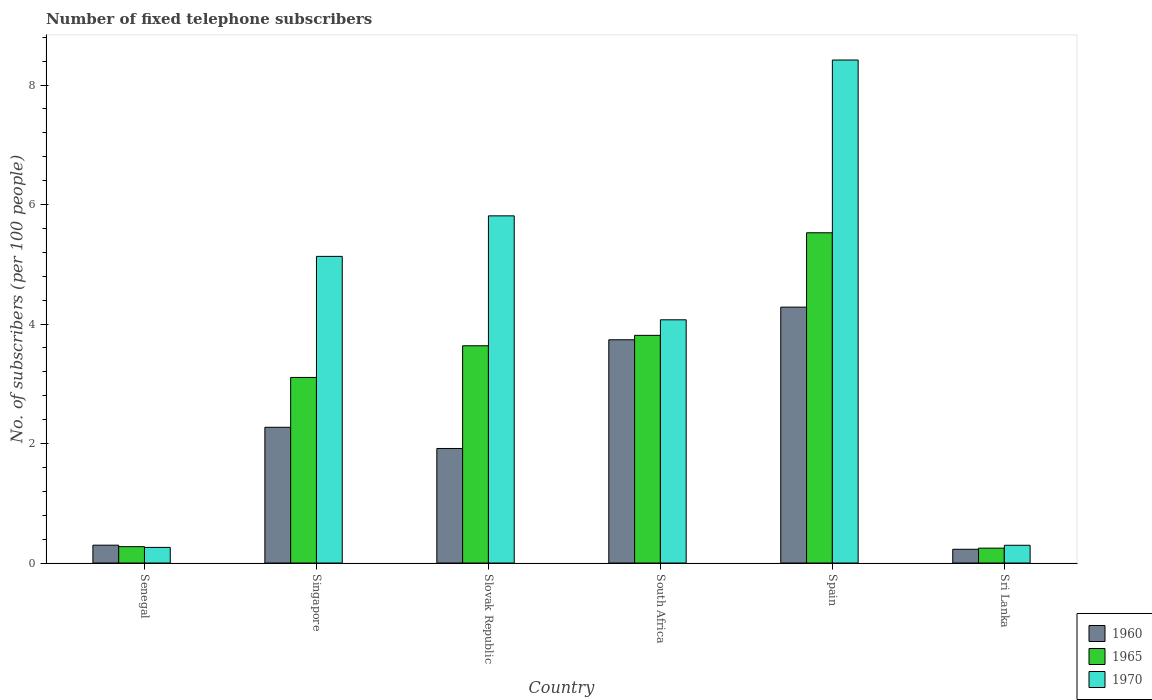How many different coloured bars are there?
Your response must be concise. 3. How many bars are there on the 1st tick from the right?
Your answer should be compact. 3. What is the label of the 3rd group of bars from the left?
Keep it short and to the point. Slovak Republic. What is the number of fixed telephone subscribers in 1970 in South Africa?
Give a very brief answer. 4.07. Across all countries, what is the maximum number of fixed telephone subscribers in 1965?
Ensure brevity in your answer.  5.53. Across all countries, what is the minimum number of fixed telephone subscribers in 1970?
Keep it short and to the point. 0.26. In which country was the number of fixed telephone subscribers in 1965 minimum?
Provide a succinct answer. Sri Lanka. What is the total number of fixed telephone subscribers in 1970 in the graph?
Offer a very short reply. 23.99. What is the difference between the number of fixed telephone subscribers in 1970 in Singapore and that in South Africa?
Give a very brief answer. 1.06. What is the difference between the number of fixed telephone subscribers in 1970 in Singapore and the number of fixed telephone subscribers in 1960 in Senegal?
Your answer should be very brief. 4.83. What is the average number of fixed telephone subscribers in 1960 per country?
Keep it short and to the point. 2.12. What is the difference between the number of fixed telephone subscribers of/in 1970 and number of fixed telephone subscribers of/in 1965 in South Africa?
Your answer should be compact. 0.26. In how many countries, is the number of fixed telephone subscribers in 1970 greater than 3.6?
Give a very brief answer. 4. What is the ratio of the number of fixed telephone subscribers in 1970 in Spain to that in Sri Lanka?
Your response must be concise. 28.33. What is the difference between the highest and the second highest number of fixed telephone subscribers in 1960?
Give a very brief answer. -1.46. What is the difference between the highest and the lowest number of fixed telephone subscribers in 1960?
Give a very brief answer. 4.05. Is the sum of the number of fixed telephone subscribers in 1960 in Singapore and Spain greater than the maximum number of fixed telephone subscribers in 1970 across all countries?
Your answer should be compact. No. What does the 3rd bar from the left in Senegal represents?
Make the answer very short. 1970. What does the 2nd bar from the right in Senegal represents?
Offer a very short reply. 1965. How many countries are there in the graph?
Provide a short and direct response. 6. Does the graph contain any zero values?
Your response must be concise. No. Does the graph contain grids?
Offer a terse response. No. What is the title of the graph?
Your answer should be compact. Number of fixed telephone subscribers. What is the label or title of the Y-axis?
Offer a terse response. No. of subscribers (per 100 people). What is the No. of subscribers (per 100 people) of 1960 in Senegal?
Provide a succinct answer. 0.3. What is the No. of subscribers (per 100 people) of 1965 in Senegal?
Your answer should be very brief. 0.27. What is the No. of subscribers (per 100 people) in 1970 in Senegal?
Your answer should be compact. 0.26. What is the No. of subscribers (per 100 people) in 1960 in Singapore?
Keep it short and to the point. 2.27. What is the No. of subscribers (per 100 people) of 1965 in Singapore?
Your response must be concise. 3.11. What is the No. of subscribers (per 100 people) in 1970 in Singapore?
Keep it short and to the point. 5.13. What is the No. of subscribers (per 100 people) of 1960 in Slovak Republic?
Offer a terse response. 1.92. What is the No. of subscribers (per 100 people) in 1965 in Slovak Republic?
Ensure brevity in your answer.  3.64. What is the No. of subscribers (per 100 people) in 1970 in Slovak Republic?
Keep it short and to the point. 5.81. What is the No. of subscribers (per 100 people) of 1960 in South Africa?
Your response must be concise. 3.74. What is the No. of subscribers (per 100 people) in 1965 in South Africa?
Your answer should be very brief. 3.81. What is the No. of subscribers (per 100 people) in 1970 in South Africa?
Make the answer very short. 4.07. What is the No. of subscribers (per 100 people) of 1960 in Spain?
Make the answer very short. 4.28. What is the No. of subscribers (per 100 people) of 1965 in Spain?
Your answer should be very brief. 5.53. What is the No. of subscribers (per 100 people) in 1970 in Spain?
Provide a succinct answer. 8.42. What is the No. of subscribers (per 100 people) in 1960 in Sri Lanka?
Offer a terse response. 0.23. What is the No. of subscribers (per 100 people) of 1965 in Sri Lanka?
Provide a succinct answer. 0.25. What is the No. of subscribers (per 100 people) in 1970 in Sri Lanka?
Give a very brief answer. 0.3. Across all countries, what is the maximum No. of subscribers (per 100 people) in 1960?
Offer a terse response. 4.28. Across all countries, what is the maximum No. of subscribers (per 100 people) of 1965?
Your response must be concise. 5.53. Across all countries, what is the maximum No. of subscribers (per 100 people) in 1970?
Offer a terse response. 8.42. Across all countries, what is the minimum No. of subscribers (per 100 people) of 1960?
Ensure brevity in your answer.  0.23. Across all countries, what is the minimum No. of subscribers (per 100 people) of 1965?
Your answer should be compact. 0.25. Across all countries, what is the minimum No. of subscribers (per 100 people) in 1970?
Your response must be concise. 0.26. What is the total No. of subscribers (per 100 people) in 1960 in the graph?
Give a very brief answer. 12.74. What is the total No. of subscribers (per 100 people) in 1965 in the graph?
Offer a terse response. 16.6. What is the total No. of subscribers (per 100 people) in 1970 in the graph?
Your answer should be compact. 23.99. What is the difference between the No. of subscribers (per 100 people) of 1960 in Senegal and that in Singapore?
Keep it short and to the point. -1.97. What is the difference between the No. of subscribers (per 100 people) in 1965 in Senegal and that in Singapore?
Give a very brief answer. -2.83. What is the difference between the No. of subscribers (per 100 people) of 1970 in Senegal and that in Singapore?
Your answer should be compact. -4.87. What is the difference between the No. of subscribers (per 100 people) in 1960 in Senegal and that in Slovak Republic?
Give a very brief answer. -1.62. What is the difference between the No. of subscribers (per 100 people) in 1965 in Senegal and that in Slovak Republic?
Offer a very short reply. -3.36. What is the difference between the No. of subscribers (per 100 people) in 1970 in Senegal and that in Slovak Republic?
Offer a terse response. -5.55. What is the difference between the No. of subscribers (per 100 people) in 1960 in Senegal and that in South Africa?
Ensure brevity in your answer.  -3.44. What is the difference between the No. of subscribers (per 100 people) in 1965 in Senegal and that in South Africa?
Your answer should be compact. -3.54. What is the difference between the No. of subscribers (per 100 people) in 1970 in Senegal and that in South Africa?
Your response must be concise. -3.81. What is the difference between the No. of subscribers (per 100 people) of 1960 in Senegal and that in Spain?
Your response must be concise. -3.98. What is the difference between the No. of subscribers (per 100 people) of 1965 in Senegal and that in Spain?
Offer a very short reply. -5.25. What is the difference between the No. of subscribers (per 100 people) in 1970 in Senegal and that in Spain?
Your answer should be compact. -8.16. What is the difference between the No. of subscribers (per 100 people) in 1960 in Senegal and that in Sri Lanka?
Offer a terse response. 0.07. What is the difference between the No. of subscribers (per 100 people) of 1965 in Senegal and that in Sri Lanka?
Your response must be concise. 0.02. What is the difference between the No. of subscribers (per 100 people) in 1970 in Senegal and that in Sri Lanka?
Your answer should be compact. -0.04. What is the difference between the No. of subscribers (per 100 people) of 1960 in Singapore and that in Slovak Republic?
Offer a terse response. 0.35. What is the difference between the No. of subscribers (per 100 people) in 1965 in Singapore and that in Slovak Republic?
Provide a succinct answer. -0.53. What is the difference between the No. of subscribers (per 100 people) of 1970 in Singapore and that in Slovak Republic?
Keep it short and to the point. -0.68. What is the difference between the No. of subscribers (per 100 people) in 1960 in Singapore and that in South Africa?
Offer a terse response. -1.46. What is the difference between the No. of subscribers (per 100 people) of 1965 in Singapore and that in South Africa?
Offer a very short reply. -0.7. What is the difference between the No. of subscribers (per 100 people) in 1970 in Singapore and that in South Africa?
Give a very brief answer. 1.06. What is the difference between the No. of subscribers (per 100 people) in 1960 in Singapore and that in Spain?
Provide a succinct answer. -2.01. What is the difference between the No. of subscribers (per 100 people) in 1965 in Singapore and that in Spain?
Your answer should be compact. -2.42. What is the difference between the No. of subscribers (per 100 people) of 1970 in Singapore and that in Spain?
Offer a terse response. -3.29. What is the difference between the No. of subscribers (per 100 people) of 1960 in Singapore and that in Sri Lanka?
Make the answer very short. 2.04. What is the difference between the No. of subscribers (per 100 people) of 1965 in Singapore and that in Sri Lanka?
Your answer should be compact. 2.86. What is the difference between the No. of subscribers (per 100 people) in 1970 in Singapore and that in Sri Lanka?
Give a very brief answer. 4.83. What is the difference between the No. of subscribers (per 100 people) in 1960 in Slovak Republic and that in South Africa?
Your answer should be compact. -1.82. What is the difference between the No. of subscribers (per 100 people) of 1965 in Slovak Republic and that in South Africa?
Your response must be concise. -0.17. What is the difference between the No. of subscribers (per 100 people) in 1970 in Slovak Republic and that in South Africa?
Provide a short and direct response. 1.74. What is the difference between the No. of subscribers (per 100 people) in 1960 in Slovak Republic and that in Spain?
Provide a succinct answer. -2.37. What is the difference between the No. of subscribers (per 100 people) of 1965 in Slovak Republic and that in Spain?
Your answer should be very brief. -1.89. What is the difference between the No. of subscribers (per 100 people) of 1970 in Slovak Republic and that in Spain?
Provide a short and direct response. -2.61. What is the difference between the No. of subscribers (per 100 people) in 1960 in Slovak Republic and that in Sri Lanka?
Your answer should be compact. 1.69. What is the difference between the No. of subscribers (per 100 people) of 1965 in Slovak Republic and that in Sri Lanka?
Offer a terse response. 3.39. What is the difference between the No. of subscribers (per 100 people) of 1970 in Slovak Republic and that in Sri Lanka?
Your answer should be very brief. 5.51. What is the difference between the No. of subscribers (per 100 people) in 1960 in South Africa and that in Spain?
Your answer should be compact. -0.55. What is the difference between the No. of subscribers (per 100 people) in 1965 in South Africa and that in Spain?
Keep it short and to the point. -1.72. What is the difference between the No. of subscribers (per 100 people) of 1970 in South Africa and that in Spain?
Provide a succinct answer. -4.35. What is the difference between the No. of subscribers (per 100 people) of 1960 in South Africa and that in Sri Lanka?
Your answer should be compact. 3.51. What is the difference between the No. of subscribers (per 100 people) in 1965 in South Africa and that in Sri Lanka?
Give a very brief answer. 3.56. What is the difference between the No. of subscribers (per 100 people) of 1970 in South Africa and that in Sri Lanka?
Make the answer very short. 3.77. What is the difference between the No. of subscribers (per 100 people) of 1960 in Spain and that in Sri Lanka?
Keep it short and to the point. 4.05. What is the difference between the No. of subscribers (per 100 people) of 1965 in Spain and that in Sri Lanka?
Offer a terse response. 5.28. What is the difference between the No. of subscribers (per 100 people) in 1970 in Spain and that in Sri Lanka?
Your response must be concise. 8.12. What is the difference between the No. of subscribers (per 100 people) of 1960 in Senegal and the No. of subscribers (per 100 people) of 1965 in Singapore?
Your response must be concise. -2.81. What is the difference between the No. of subscribers (per 100 people) of 1960 in Senegal and the No. of subscribers (per 100 people) of 1970 in Singapore?
Your answer should be compact. -4.83. What is the difference between the No. of subscribers (per 100 people) in 1965 in Senegal and the No. of subscribers (per 100 people) in 1970 in Singapore?
Offer a terse response. -4.86. What is the difference between the No. of subscribers (per 100 people) in 1960 in Senegal and the No. of subscribers (per 100 people) in 1965 in Slovak Republic?
Offer a very short reply. -3.34. What is the difference between the No. of subscribers (per 100 people) in 1960 in Senegal and the No. of subscribers (per 100 people) in 1970 in Slovak Republic?
Make the answer very short. -5.51. What is the difference between the No. of subscribers (per 100 people) in 1965 in Senegal and the No. of subscribers (per 100 people) in 1970 in Slovak Republic?
Provide a short and direct response. -5.54. What is the difference between the No. of subscribers (per 100 people) of 1960 in Senegal and the No. of subscribers (per 100 people) of 1965 in South Africa?
Give a very brief answer. -3.51. What is the difference between the No. of subscribers (per 100 people) in 1960 in Senegal and the No. of subscribers (per 100 people) in 1970 in South Africa?
Provide a succinct answer. -3.77. What is the difference between the No. of subscribers (per 100 people) of 1965 in Senegal and the No. of subscribers (per 100 people) of 1970 in South Africa?
Offer a very short reply. -3.8. What is the difference between the No. of subscribers (per 100 people) in 1960 in Senegal and the No. of subscribers (per 100 people) in 1965 in Spain?
Offer a very short reply. -5.23. What is the difference between the No. of subscribers (per 100 people) in 1960 in Senegal and the No. of subscribers (per 100 people) in 1970 in Spain?
Keep it short and to the point. -8.12. What is the difference between the No. of subscribers (per 100 people) in 1965 in Senegal and the No. of subscribers (per 100 people) in 1970 in Spain?
Offer a very short reply. -8.14. What is the difference between the No. of subscribers (per 100 people) of 1960 in Senegal and the No. of subscribers (per 100 people) of 1965 in Sri Lanka?
Offer a terse response. 0.05. What is the difference between the No. of subscribers (per 100 people) of 1960 in Senegal and the No. of subscribers (per 100 people) of 1970 in Sri Lanka?
Provide a short and direct response. 0. What is the difference between the No. of subscribers (per 100 people) in 1965 in Senegal and the No. of subscribers (per 100 people) in 1970 in Sri Lanka?
Offer a very short reply. -0.02. What is the difference between the No. of subscribers (per 100 people) of 1960 in Singapore and the No. of subscribers (per 100 people) of 1965 in Slovak Republic?
Provide a succinct answer. -1.36. What is the difference between the No. of subscribers (per 100 people) in 1960 in Singapore and the No. of subscribers (per 100 people) in 1970 in Slovak Republic?
Provide a short and direct response. -3.54. What is the difference between the No. of subscribers (per 100 people) of 1965 in Singapore and the No. of subscribers (per 100 people) of 1970 in Slovak Republic?
Offer a very short reply. -2.7. What is the difference between the No. of subscribers (per 100 people) of 1960 in Singapore and the No. of subscribers (per 100 people) of 1965 in South Africa?
Provide a short and direct response. -1.54. What is the difference between the No. of subscribers (per 100 people) in 1960 in Singapore and the No. of subscribers (per 100 people) in 1970 in South Africa?
Your answer should be compact. -1.8. What is the difference between the No. of subscribers (per 100 people) of 1965 in Singapore and the No. of subscribers (per 100 people) of 1970 in South Africa?
Your answer should be compact. -0.96. What is the difference between the No. of subscribers (per 100 people) of 1960 in Singapore and the No. of subscribers (per 100 people) of 1965 in Spain?
Offer a terse response. -3.26. What is the difference between the No. of subscribers (per 100 people) of 1960 in Singapore and the No. of subscribers (per 100 people) of 1970 in Spain?
Your answer should be compact. -6.15. What is the difference between the No. of subscribers (per 100 people) of 1965 in Singapore and the No. of subscribers (per 100 people) of 1970 in Spain?
Give a very brief answer. -5.31. What is the difference between the No. of subscribers (per 100 people) of 1960 in Singapore and the No. of subscribers (per 100 people) of 1965 in Sri Lanka?
Your answer should be compact. 2.02. What is the difference between the No. of subscribers (per 100 people) in 1960 in Singapore and the No. of subscribers (per 100 people) in 1970 in Sri Lanka?
Your answer should be compact. 1.97. What is the difference between the No. of subscribers (per 100 people) of 1965 in Singapore and the No. of subscribers (per 100 people) of 1970 in Sri Lanka?
Provide a short and direct response. 2.81. What is the difference between the No. of subscribers (per 100 people) in 1960 in Slovak Republic and the No. of subscribers (per 100 people) in 1965 in South Africa?
Provide a short and direct response. -1.89. What is the difference between the No. of subscribers (per 100 people) of 1960 in Slovak Republic and the No. of subscribers (per 100 people) of 1970 in South Africa?
Provide a short and direct response. -2.15. What is the difference between the No. of subscribers (per 100 people) in 1965 in Slovak Republic and the No. of subscribers (per 100 people) in 1970 in South Africa?
Offer a very short reply. -0.43. What is the difference between the No. of subscribers (per 100 people) in 1960 in Slovak Republic and the No. of subscribers (per 100 people) in 1965 in Spain?
Make the answer very short. -3.61. What is the difference between the No. of subscribers (per 100 people) in 1960 in Slovak Republic and the No. of subscribers (per 100 people) in 1970 in Spain?
Provide a succinct answer. -6.5. What is the difference between the No. of subscribers (per 100 people) in 1965 in Slovak Republic and the No. of subscribers (per 100 people) in 1970 in Spain?
Ensure brevity in your answer.  -4.78. What is the difference between the No. of subscribers (per 100 people) in 1960 in Slovak Republic and the No. of subscribers (per 100 people) in 1965 in Sri Lanka?
Provide a short and direct response. 1.67. What is the difference between the No. of subscribers (per 100 people) of 1960 in Slovak Republic and the No. of subscribers (per 100 people) of 1970 in Sri Lanka?
Offer a terse response. 1.62. What is the difference between the No. of subscribers (per 100 people) in 1965 in Slovak Republic and the No. of subscribers (per 100 people) in 1970 in Sri Lanka?
Provide a short and direct response. 3.34. What is the difference between the No. of subscribers (per 100 people) in 1960 in South Africa and the No. of subscribers (per 100 people) in 1965 in Spain?
Offer a very short reply. -1.79. What is the difference between the No. of subscribers (per 100 people) in 1960 in South Africa and the No. of subscribers (per 100 people) in 1970 in Spain?
Ensure brevity in your answer.  -4.68. What is the difference between the No. of subscribers (per 100 people) of 1965 in South Africa and the No. of subscribers (per 100 people) of 1970 in Spain?
Provide a succinct answer. -4.61. What is the difference between the No. of subscribers (per 100 people) in 1960 in South Africa and the No. of subscribers (per 100 people) in 1965 in Sri Lanka?
Offer a terse response. 3.49. What is the difference between the No. of subscribers (per 100 people) of 1960 in South Africa and the No. of subscribers (per 100 people) of 1970 in Sri Lanka?
Offer a very short reply. 3.44. What is the difference between the No. of subscribers (per 100 people) in 1965 in South Africa and the No. of subscribers (per 100 people) in 1970 in Sri Lanka?
Provide a short and direct response. 3.51. What is the difference between the No. of subscribers (per 100 people) in 1960 in Spain and the No. of subscribers (per 100 people) in 1965 in Sri Lanka?
Keep it short and to the point. 4.03. What is the difference between the No. of subscribers (per 100 people) in 1960 in Spain and the No. of subscribers (per 100 people) in 1970 in Sri Lanka?
Make the answer very short. 3.99. What is the difference between the No. of subscribers (per 100 people) of 1965 in Spain and the No. of subscribers (per 100 people) of 1970 in Sri Lanka?
Make the answer very short. 5.23. What is the average No. of subscribers (per 100 people) of 1960 per country?
Provide a short and direct response. 2.12. What is the average No. of subscribers (per 100 people) in 1965 per country?
Provide a succinct answer. 2.77. What is the average No. of subscribers (per 100 people) of 1970 per country?
Provide a succinct answer. 4. What is the difference between the No. of subscribers (per 100 people) in 1960 and No. of subscribers (per 100 people) in 1965 in Senegal?
Offer a very short reply. 0.02. What is the difference between the No. of subscribers (per 100 people) in 1960 and No. of subscribers (per 100 people) in 1970 in Senegal?
Give a very brief answer. 0.04. What is the difference between the No. of subscribers (per 100 people) of 1965 and No. of subscribers (per 100 people) of 1970 in Senegal?
Give a very brief answer. 0.01. What is the difference between the No. of subscribers (per 100 people) in 1960 and No. of subscribers (per 100 people) in 1965 in Singapore?
Keep it short and to the point. -0.83. What is the difference between the No. of subscribers (per 100 people) of 1960 and No. of subscribers (per 100 people) of 1970 in Singapore?
Your response must be concise. -2.86. What is the difference between the No. of subscribers (per 100 people) of 1965 and No. of subscribers (per 100 people) of 1970 in Singapore?
Your answer should be very brief. -2.03. What is the difference between the No. of subscribers (per 100 people) in 1960 and No. of subscribers (per 100 people) in 1965 in Slovak Republic?
Provide a short and direct response. -1.72. What is the difference between the No. of subscribers (per 100 people) in 1960 and No. of subscribers (per 100 people) in 1970 in Slovak Republic?
Keep it short and to the point. -3.89. What is the difference between the No. of subscribers (per 100 people) of 1965 and No. of subscribers (per 100 people) of 1970 in Slovak Republic?
Keep it short and to the point. -2.17. What is the difference between the No. of subscribers (per 100 people) in 1960 and No. of subscribers (per 100 people) in 1965 in South Africa?
Your answer should be compact. -0.07. What is the difference between the No. of subscribers (per 100 people) in 1960 and No. of subscribers (per 100 people) in 1970 in South Africa?
Keep it short and to the point. -0.33. What is the difference between the No. of subscribers (per 100 people) of 1965 and No. of subscribers (per 100 people) of 1970 in South Africa?
Provide a succinct answer. -0.26. What is the difference between the No. of subscribers (per 100 people) in 1960 and No. of subscribers (per 100 people) in 1965 in Spain?
Offer a terse response. -1.24. What is the difference between the No. of subscribers (per 100 people) in 1960 and No. of subscribers (per 100 people) in 1970 in Spain?
Give a very brief answer. -4.14. What is the difference between the No. of subscribers (per 100 people) of 1965 and No. of subscribers (per 100 people) of 1970 in Spain?
Offer a terse response. -2.89. What is the difference between the No. of subscribers (per 100 people) of 1960 and No. of subscribers (per 100 people) of 1965 in Sri Lanka?
Keep it short and to the point. -0.02. What is the difference between the No. of subscribers (per 100 people) in 1960 and No. of subscribers (per 100 people) in 1970 in Sri Lanka?
Offer a terse response. -0.07. What is the difference between the No. of subscribers (per 100 people) in 1965 and No. of subscribers (per 100 people) in 1970 in Sri Lanka?
Ensure brevity in your answer.  -0.05. What is the ratio of the No. of subscribers (per 100 people) of 1960 in Senegal to that in Singapore?
Your answer should be very brief. 0.13. What is the ratio of the No. of subscribers (per 100 people) in 1965 in Senegal to that in Singapore?
Provide a short and direct response. 0.09. What is the ratio of the No. of subscribers (per 100 people) of 1970 in Senegal to that in Singapore?
Your answer should be compact. 0.05. What is the ratio of the No. of subscribers (per 100 people) in 1960 in Senegal to that in Slovak Republic?
Your answer should be compact. 0.16. What is the ratio of the No. of subscribers (per 100 people) of 1965 in Senegal to that in Slovak Republic?
Offer a terse response. 0.08. What is the ratio of the No. of subscribers (per 100 people) in 1970 in Senegal to that in Slovak Republic?
Provide a short and direct response. 0.04. What is the ratio of the No. of subscribers (per 100 people) of 1965 in Senegal to that in South Africa?
Ensure brevity in your answer.  0.07. What is the ratio of the No. of subscribers (per 100 people) of 1970 in Senegal to that in South Africa?
Keep it short and to the point. 0.06. What is the ratio of the No. of subscribers (per 100 people) of 1960 in Senegal to that in Spain?
Ensure brevity in your answer.  0.07. What is the ratio of the No. of subscribers (per 100 people) of 1965 in Senegal to that in Spain?
Offer a terse response. 0.05. What is the ratio of the No. of subscribers (per 100 people) of 1970 in Senegal to that in Spain?
Make the answer very short. 0.03. What is the ratio of the No. of subscribers (per 100 people) in 1960 in Senegal to that in Sri Lanka?
Make the answer very short. 1.3. What is the ratio of the No. of subscribers (per 100 people) in 1965 in Senegal to that in Sri Lanka?
Provide a succinct answer. 1.1. What is the ratio of the No. of subscribers (per 100 people) in 1970 in Senegal to that in Sri Lanka?
Offer a terse response. 0.88. What is the ratio of the No. of subscribers (per 100 people) of 1960 in Singapore to that in Slovak Republic?
Ensure brevity in your answer.  1.18. What is the ratio of the No. of subscribers (per 100 people) in 1965 in Singapore to that in Slovak Republic?
Your response must be concise. 0.85. What is the ratio of the No. of subscribers (per 100 people) in 1970 in Singapore to that in Slovak Republic?
Give a very brief answer. 0.88. What is the ratio of the No. of subscribers (per 100 people) of 1960 in Singapore to that in South Africa?
Provide a succinct answer. 0.61. What is the ratio of the No. of subscribers (per 100 people) in 1965 in Singapore to that in South Africa?
Provide a short and direct response. 0.82. What is the ratio of the No. of subscribers (per 100 people) of 1970 in Singapore to that in South Africa?
Offer a terse response. 1.26. What is the ratio of the No. of subscribers (per 100 people) of 1960 in Singapore to that in Spain?
Ensure brevity in your answer.  0.53. What is the ratio of the No. of subscribers (per 100 people) in 1965 in Singapore to that in Spain?
Provide a succinct answer. 0.56. What is the ratio of the No. of subscribers (per 100 people) of 1970 in Singapore to that in Spain?
Provide a short and direct response. 0.61. What is the ratio of the No. of subscribers (per 100 people) in 1960 in Singapore to that in Sri Lanka?
Offer a terse response. 9.87. What is the ratio of the No. of subscribers (per 100 people) in 1965 in Singapore to that in Sri Lanka?
Offer a very short reply. 12.46. What is the ratio of the No. of subscribers (per 100 people) of 1970 in Singapore to that in Sri Lanka?
Offer a very short reply. 17.27. What is the ratio of the No. of subscribers (per 100 people) in 1960 in Slovak Republic to that in South Africa?
Your answer should be compact. 0.51. What is the ratio of the No. of subscribers (per 100 people) of 1965 in Slovak Republic to that in South Africa?
Ensure brevity in your answer.  0.95. What is the ratio of the No. of subscribers (per 100 people) in 1970 in Slovak Republic to that in South Africa?
Give a very brief answer. 1.43. What is the ratio of the No. of subscribers (per 100 people) in 1960 in Slovak Republic to that in Spain?
Provide a short and direct response. 0.45. What is the ratio of the No. of subscribers (per 100 people) of 1965 in Slovak Republic to that in Spain?
Your response must be concise. 0.66. What is the ratio of the No. of subscribers (per 100 people) of 1970 in Slovak Republic to that in Spain?
Your response must be concise. 0.69. What is the ratio of the No. of subscribers (per 100 people) in 1960 in Slovak Republic to that in Sri Lanka?
Your answer should be very brief. 8.33. What is the ratio of the No. of subscribers (per 100 people) of 1965 in Slovak Republic to that in Sri Lanka?
Offer a terse response. 14.59. What is the ratio of the No. of subscribers (per 100 people) in 1970 in Slovak Republic to that in Sri Lanka?
Your answer should be compact. 19.55. What is the ratio of the No. of subscribers (per 100 people) of 1960 in South Africa to that in Spain?
Your answer should be very brief. 0.87. What is the ratio of the No. of subscribers (per 100 people) of 1965 in South Africa to that in Spain?
Give a very brief answer. 0.69. What is the ratio of the No. of subscribers (per 100 people) of 1970 in South Africa to that in Spain?
Offer a very short reply. 0.48. What is the ratio of the No. of subscribers (per 100 people) in 1960 in South Africa to that in Sri Lanka?
Provide a short and direct response. 16.24. What is the ratio of the No. of subscribers (per 100 people) of 1965 in South Africa to that in Sri Lanka?
Your answer should be very brief. 15.29. What is the ratio of the No. of subscribers (per 100 people) of 1970 in South Africa to that in Sri Lanka?
Make the answer very short. 13.7. What is the ratio of the No. of subscribers (per 100 people) of 1960 in Spain to that in Sri Lanka?
Your answer should be very brief. 18.61. What is the ratio of the No. of subscribers (per 100 people) of 1965 in Spain to that in Sri Lanka?
Offer a very short reply. 22.18. What is the ratio of the No. of subscribers (per 100 people) of 1970 in Spain to that in Sri Lanka?
Provide a short and direct response. 28.33. What is the difference between the highest and the second highest No. of subscribers (per 100 people) of 1960?
Make the answer very short. 0.55. What is the difference between the highest and the second highest No. of subscribers (per 100 people) of 1965?
Provide a succinct answer. 1.72. What is the difference between the highest and the second highest No. of subscribers (per 100 people) of 1970?
Offer a terse response. 2.61. What is the difference between the highest and the lowest No. of subscribers (per 100 people) of 1960?
Provide a short and direct response. 4.05. What is the difference between the highest and the lowest No. of subscribers (per 100 people) in 1965?
Make the answer very short. 5.28. What is the difference between the highest and the lowest No. of subscribers (per 100 people) of 1970?
Provide a short and direct response. 8.16. 